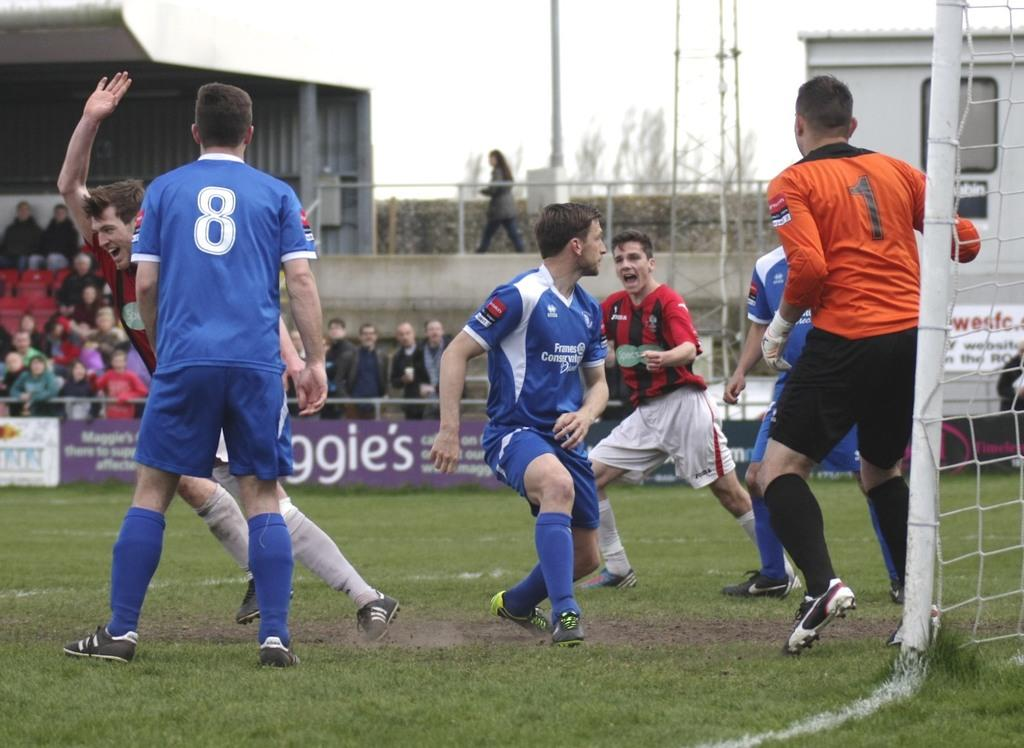<image>
Describe the image concisely. Player number 1 is defending the goal while player 8 look at a player with his arm up. 